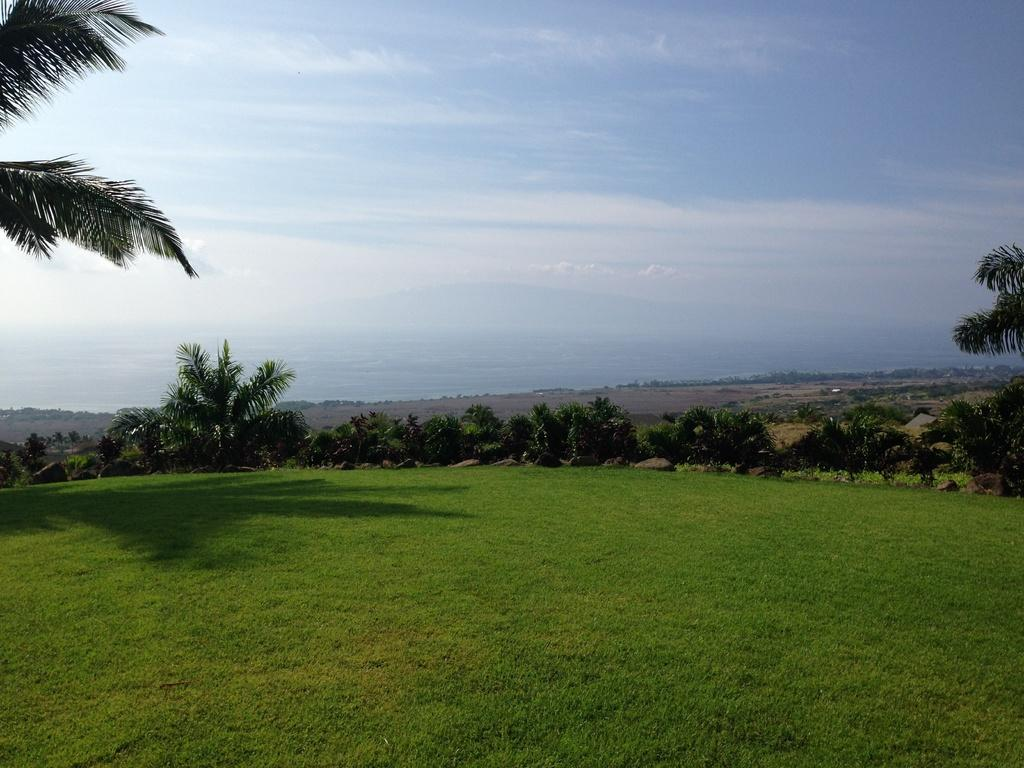What type of vegetation can be seen in the image? There is grass in the image. What other natural elements are present in the image? There are trees in the image. What can be seen in the sky in the image? There are clouds visible in the image. How does the boy's digestion process affect the grass in the image? There is no boy present in the image, so his digestion process cannot affect the grass. 